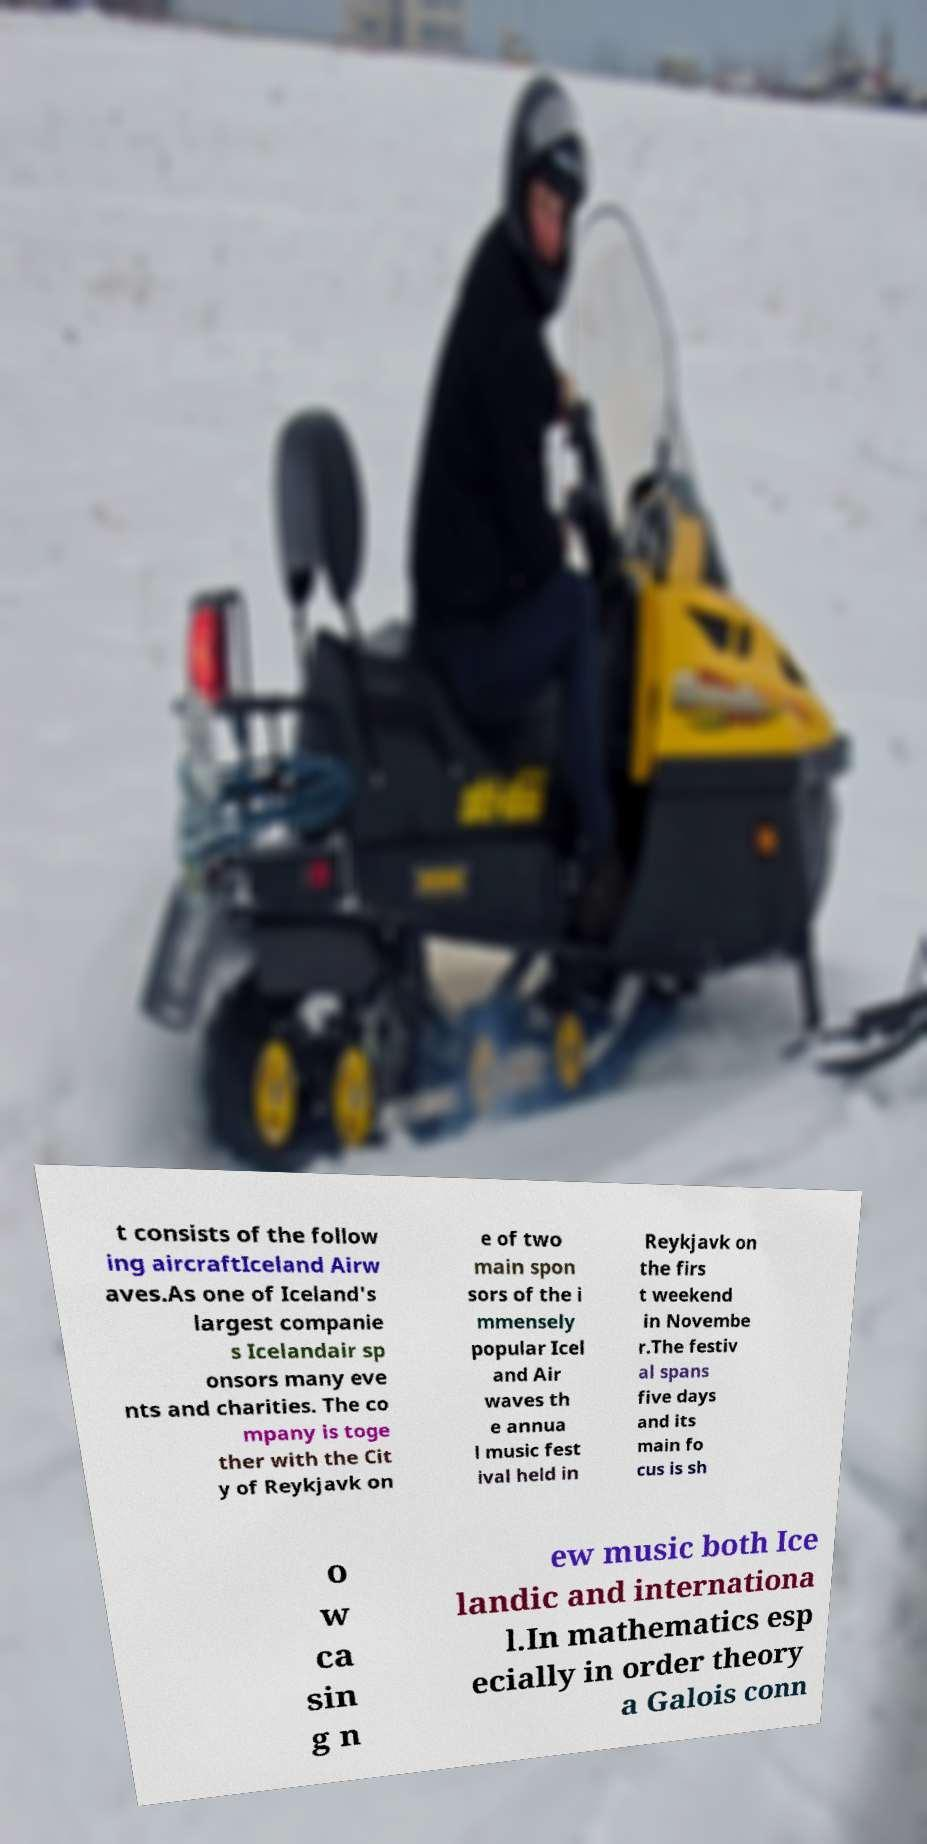Can you accurately transcribe the text from the provided image for me? t consists of the follow ing aircraftIceland Airw aves.As one of Iceland's largest companie s Icelandair sp onsors many eve nts and charities. The co mpany is toge ther with the Cit y of Reykjavk on e of two main spon sors of the i mmensely popular Icel and Air waves th e annua l music fest ival held in Reykjavk on the firs t weekend in Novembe r.The festiv al spans five days and its main fo cus is sh o w ca sin g n ew music both Ice landic and internationa l.In mathematics esp ecially in order theory a Galois conn 